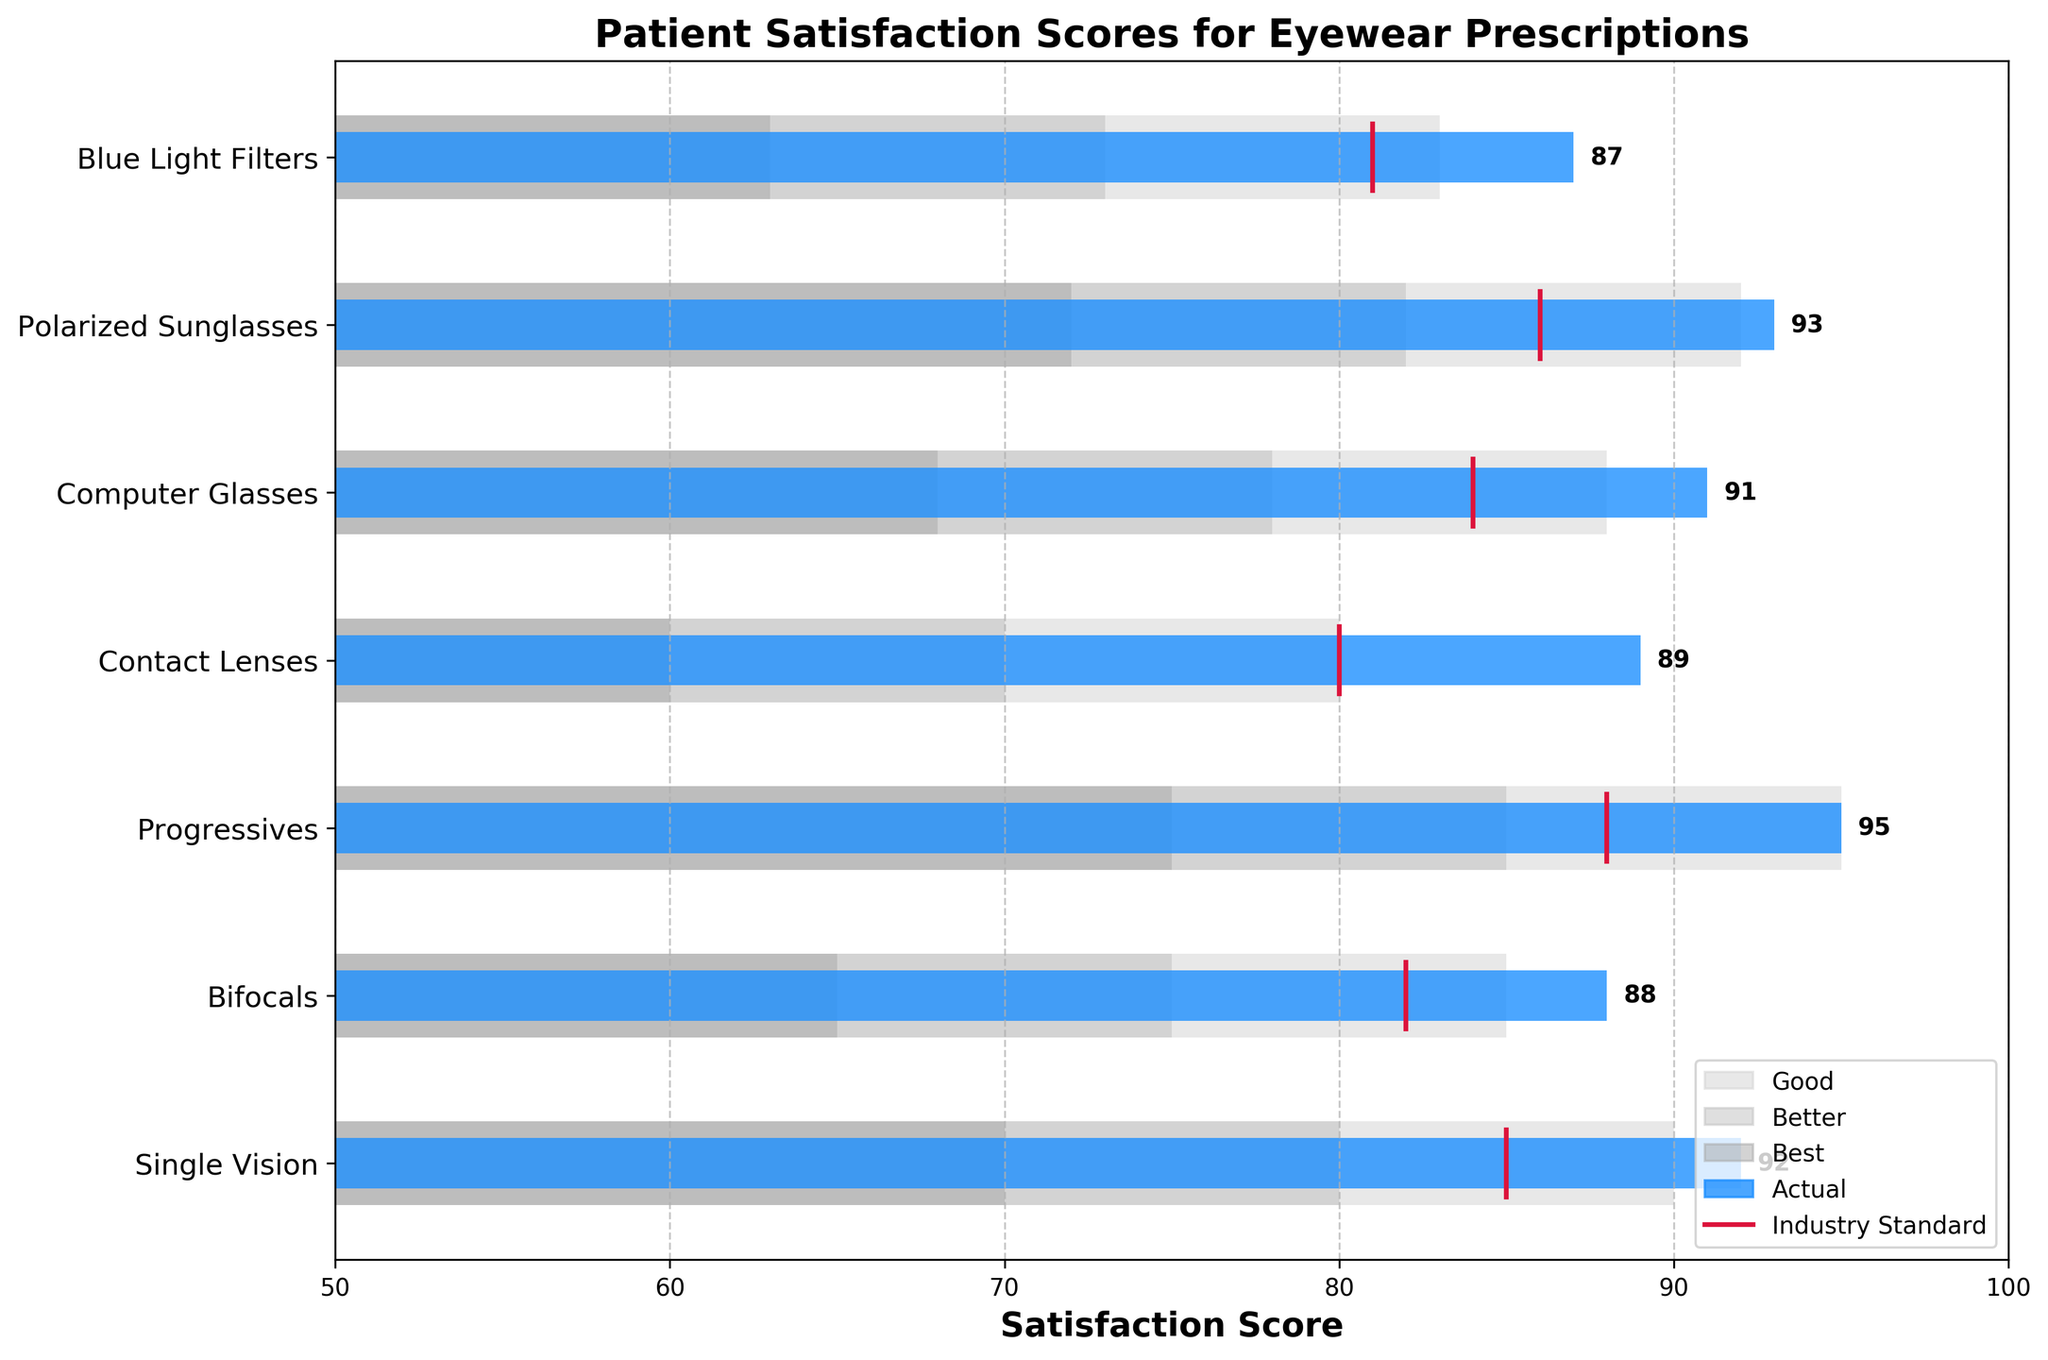What is the title of the chart? The title is found at the top of the chart. It explains what the entire chart is about.
Answer: Patient Satisfaction Scores for Eyewear Prescriptions What is the satisfaction score for Bifocals? Find the blue bar on the row labeled "Bifocals" and look for the number next to it.
Answer: 88 What is the best range for Contact Lenses? The darkest area in the horizontal bar for Contact Lenses shows the "Best" range.
Answer: 60-70 Which category has the highest satisfaction score? Look for the longest blue bar and check the value next to it.
Answer: Progressives Are the satisfaction scores for Blue Light Filters above or below the industry standard? Compare the blue bar for Blue Light Filters with the crimson line marking the industry standard.
Answer: Above What is the difference between the satisfaction scores of Single Vision and Polarized Sunglasses? Subtract the satisfaction score of Polarized Sunglasses from Single Vision (i.e., 92 - 93).
Answer: -1 How many categories have a satisfaction score above 90? Count the number of blue bars that extend past the 90 marks on the x-axis.
Answer: 3 Which category has the smallest gap between its satisfaction score and the industry standard? Calculate the difference between the blue bar and the crimson line for each category and find the smallest value.
Answer: Blue Light Filters What is the average satisfaction score for all categories? Sum up the satisfaction scores for all categories (92+88+95+89+91+93+87) and divide by the number of categories (7).
Answer: 90.71 Which category falls within the highest industry standard range? The industry standard ranges are the crimson lines. Progressives have the highest standard of 88, so it matches its category.
Answer: Progressives 